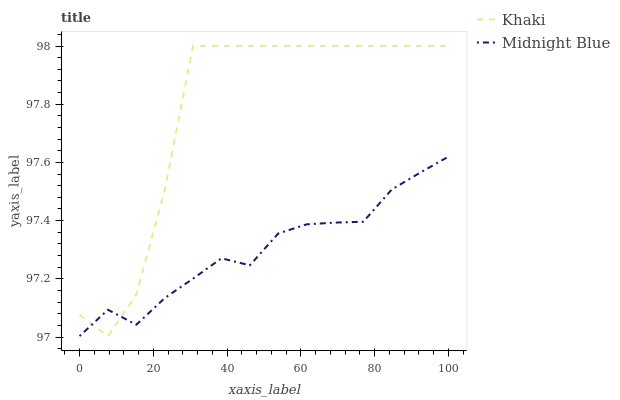Does Midnight Blue have the minimum area under the curve?
Answer yes or no. Yes. Does Khaki have the maximum area under the curve?
Answer yes or no. Yes. Does Midnight Blue have the maximum area under the curve?
Answer yes or no. No. Is Midnight Blue the smoothest?
Answer yes or no. Yes. Is Khaki the roughest?
Answer yes or no. Yes. Is Midnight Blue the roughest?
Answer yes or no. No. Does Midnight Blue have the lowest value?
Answer yes or no. No. Does Khaki have the highest value?
Answer yes or no. Yes. Does Midnight Blue have the highest value?
Answer yes or no. No. Does Khaki intersect Midnight Blue?
Answer yes or no. Yes. Is Khaki less than Midnight Blue?
Answer yes or no. No. Is Khaki greater than Midnight Blue?
Answer yes or no. No. 